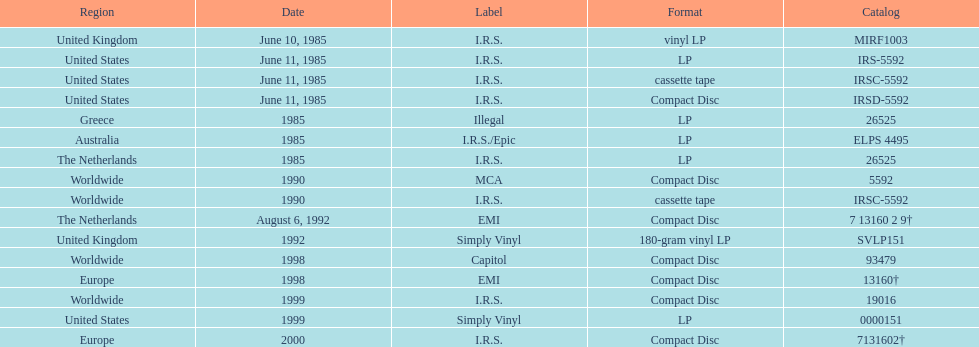In how many countries was the album released before 1990? 5. 